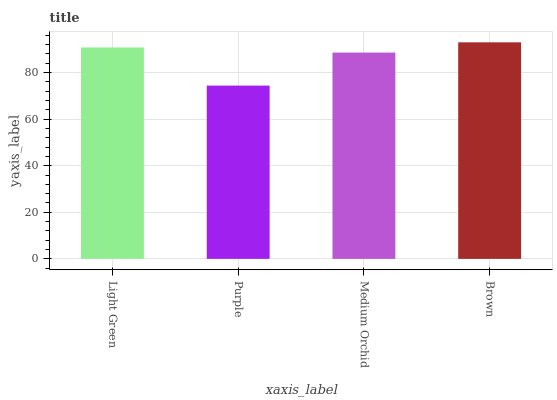Is Purple the minimum?
Answer yes or no. Yes. Is Brown the maximum?
Answer yes or no. Yes. Is Medium Orchid the minimum?
Answer yes or no. No. Is Medium Orchid the maximum?
Answer yes or no. No. Is Medium Orchid greater than Purple?
Answer yes or no. Yes. Is Purple less than Medium Orchid?
Answer yes or no. Yes. Is Purple greater than Medium Orchid?
Answer yes or no. No. Is Medium Orchid less than Purple?
Answer yes or no. No. Is Light Green the high median?
Answer yes or no. Yes. Is Medium Orchid the low median?
Answer yes or no. Yes. Is Medium Orchid the high median?
Answer yes or no. No. Is Purple the low median?
Answer yes or no. No. 